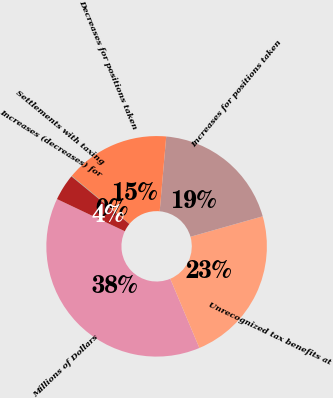Convert chart. <chart><loc_0><loc_0><loc_500><loc_500><pie_chart><fcel>Millions of Dollars<fcel>Unrecognized tax benefits at<fcel>Increases for positions taken<fcel>Decreases for positions taken<fcel>Settlements with taxing<fcel>Increases (decreases) for<nl><fcel>38.39%<fcel>23.05%<fcel>19.22%<fcel>15.39%<fcel>0.06%<fcel>3.89%<nl></chart> 